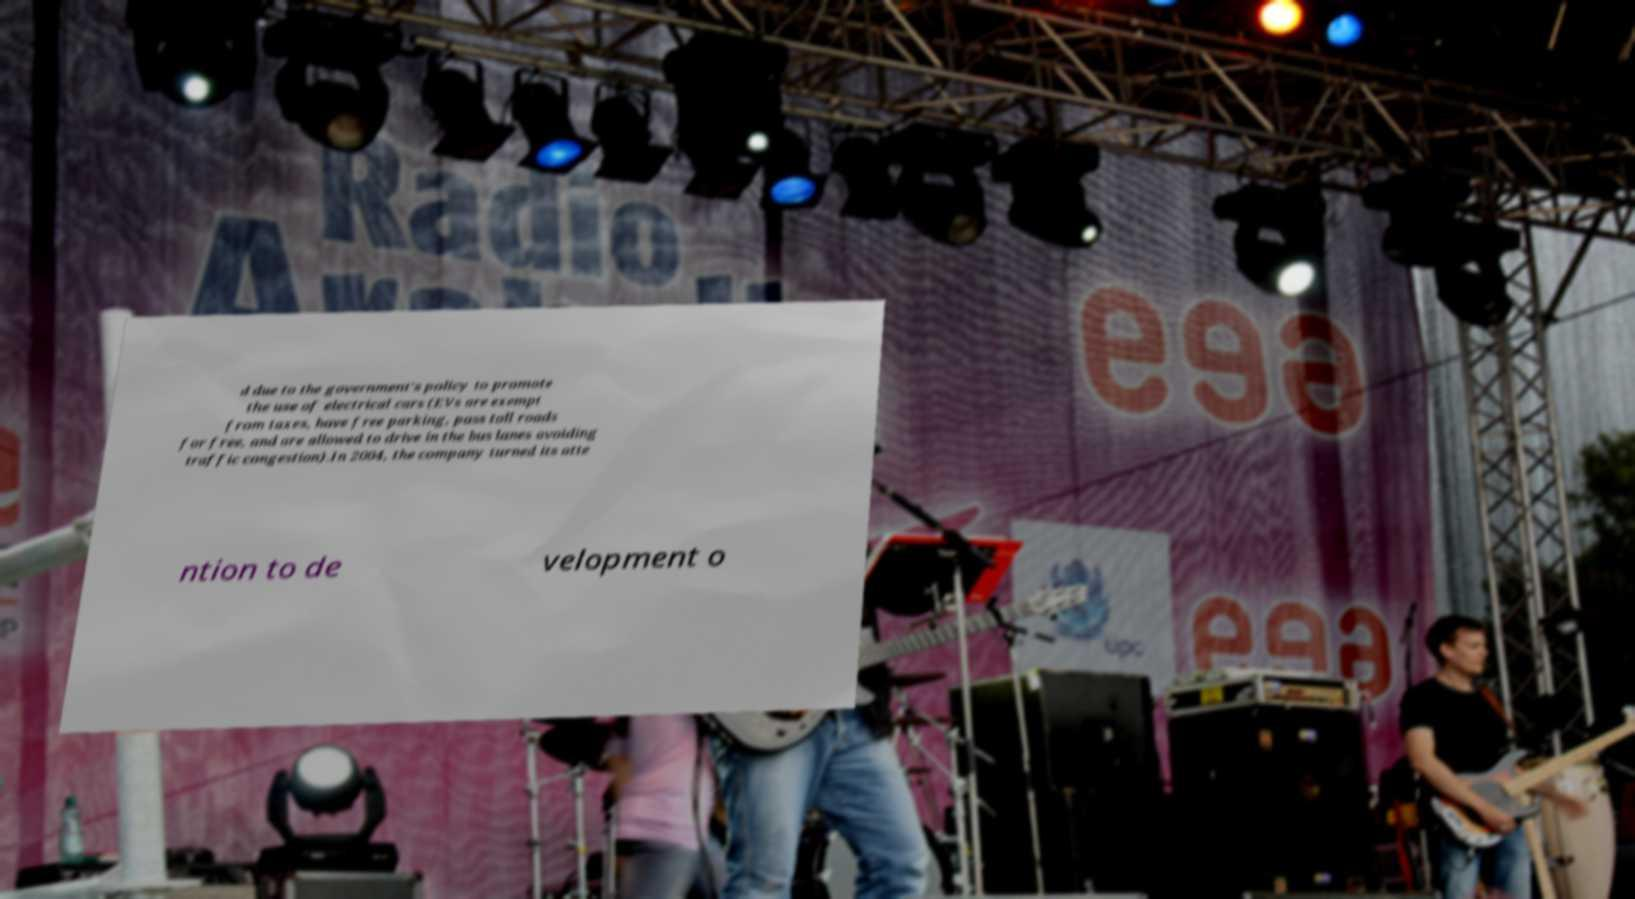Can you accurately transcribe the text from the provided image for me? d due to the government's policy to promote the use of electrical cars (EVs are exempt from taxes, have free parking, pass toll roads for free, and are allowed to drive in the bus lanes avoiding traffic congestion).In 2004, the company turned its atte ntion to de velopment o 